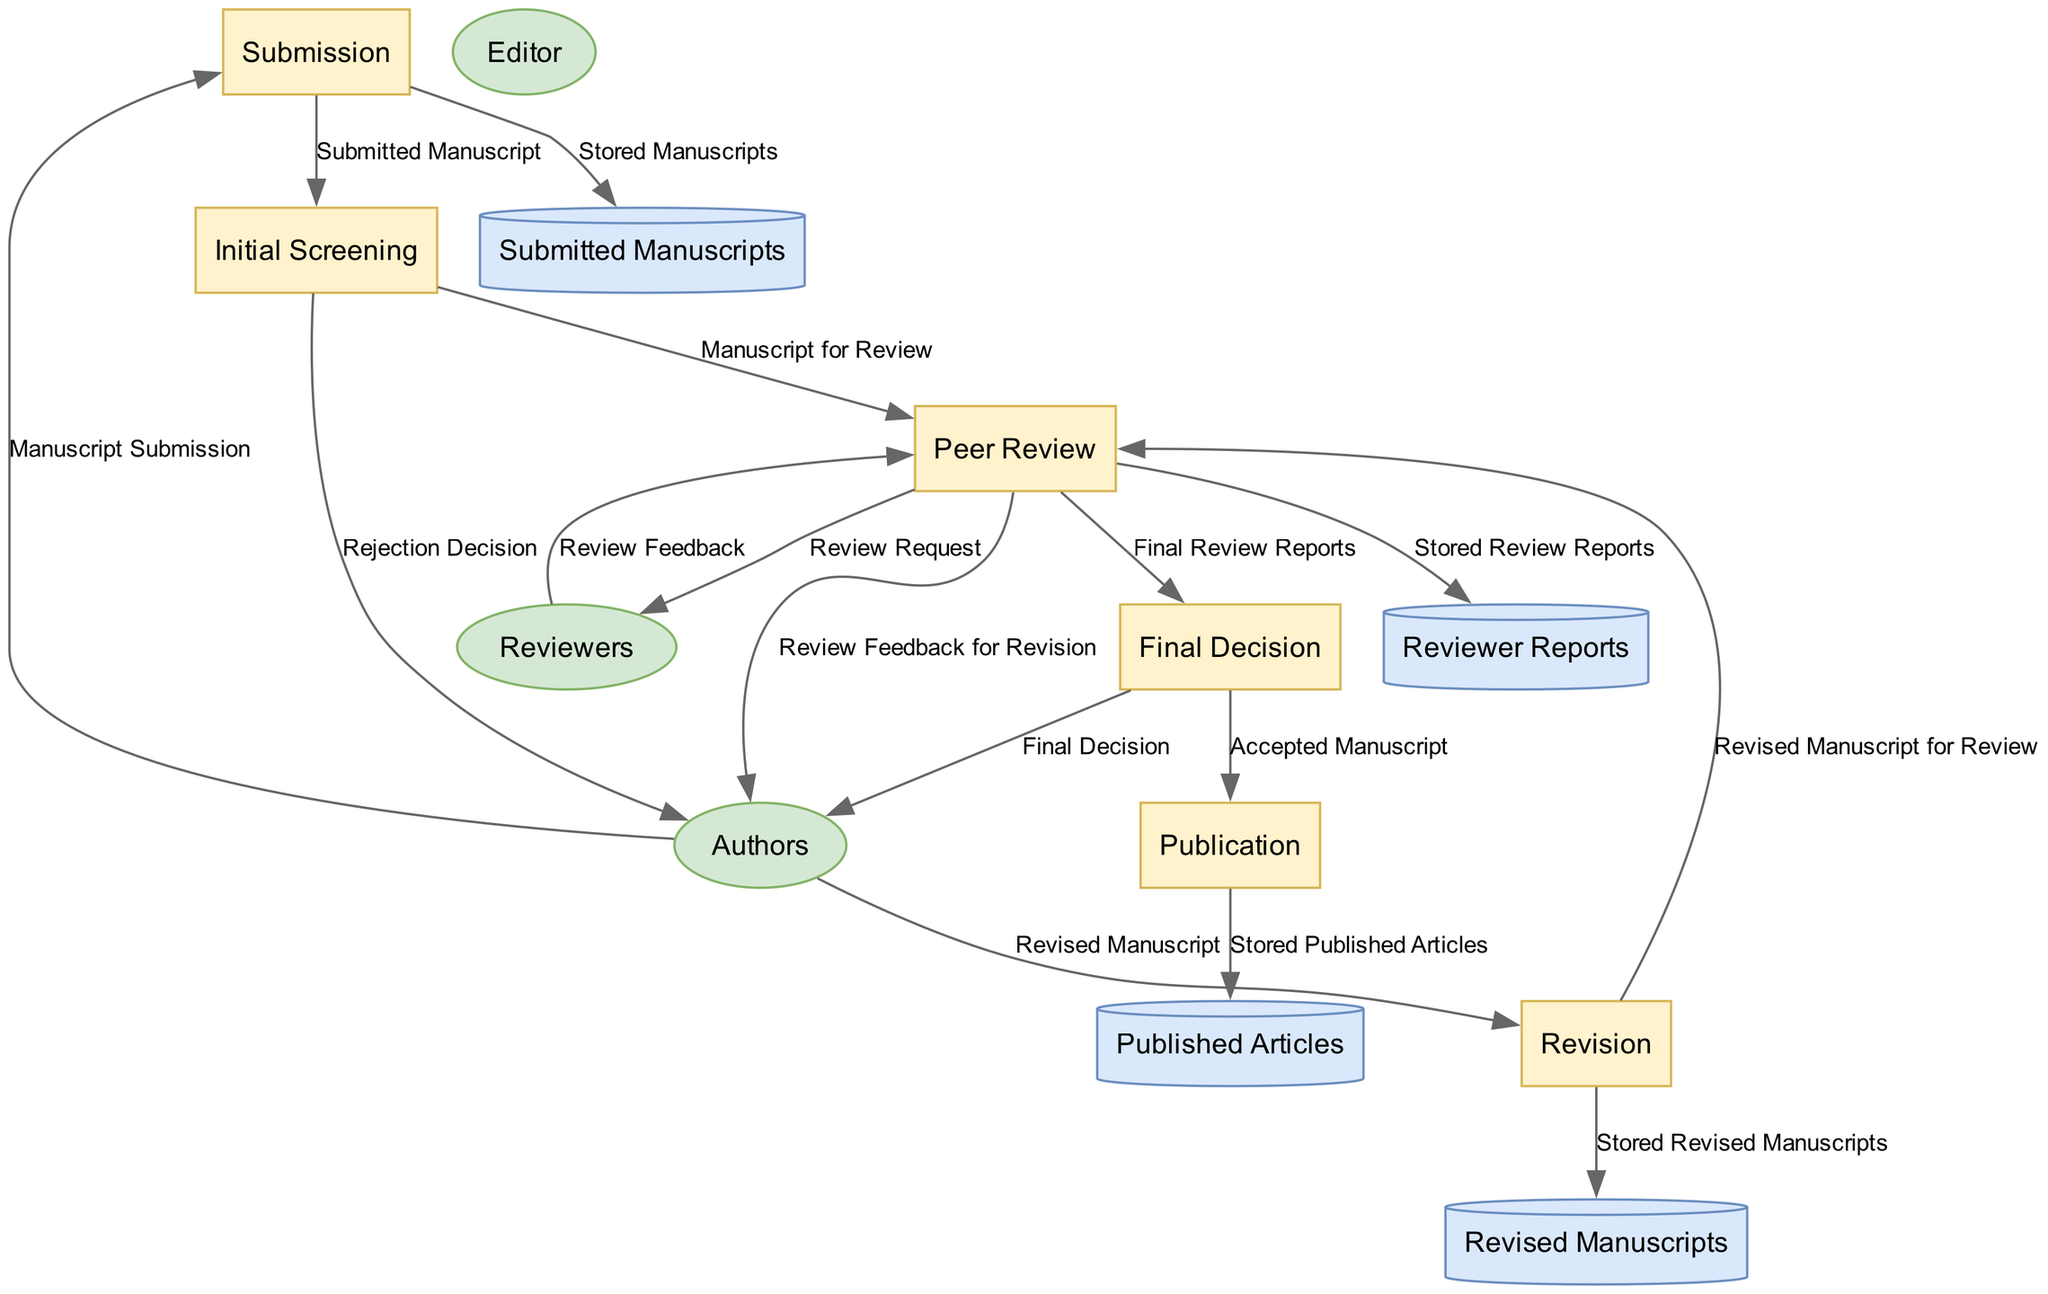What is the first process in the diagram? The first process listed in the diagram is "Submission," which refers to the initial submission of the manuscript by the authors.
Answer: Submission How many data stores are represented in the diagram? There are four data stores in the diagram: "Submitted Manuscripts," "Reviewer Reports," "Revised Manuscripts," and "Published Articles."
Answer: Four What data is sent from the Peer Review process to the Final Decision process? The data sent from the Peer Review process to the Final Decision process is "Final Review Reports."
Answer: Final Review Reports Who performs the initial screening of the manuscript? The entity responsible for the initial screening of the manuscript is the "Editor."
Answer: Editor What happens if the manuscript is found unsuitable during the Initial Screening? If the manuscript is found unsuitable, the Editor issues a "Rejection Decision" to the Authors.
Answer: Rejection Decision How many edges are connected to the revision process? There are three edges connected to the Revision process: one from the Authors with the "Revised Manuscript," one to the Peer Review process with the "Revised Manuscript for Review," and another to the data store for "Stored Revised Manuscripts."
Answer: Three What type of entity provides feedback during the Peer Review process? The type of entity that provides feedback during the Peer Review process is "Reviewers," who are experts in the field.
Answer: Reviewers What is the final output of the process once the manuscript is accepted? The final output of the process after acceptance is the "Accepted Manuscript."
Answer: Accepted Manuscript Which process directly stores the published articles? The process that directly stores the published articles is "Publication."
Answer: Publication 